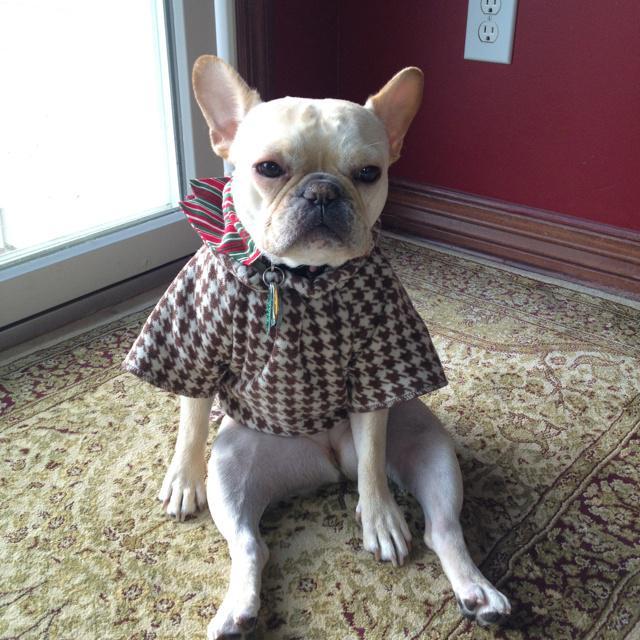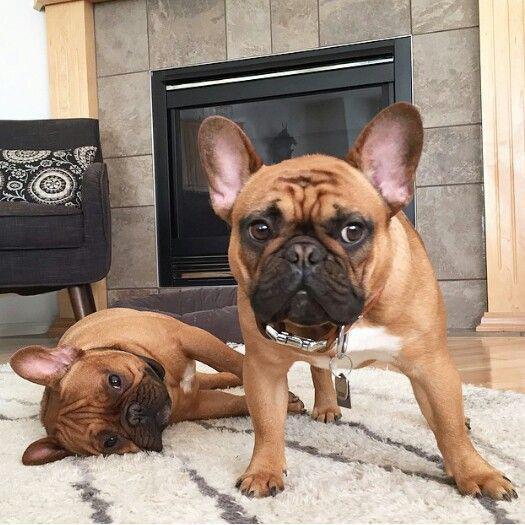The first image is the image on the left, the second image is the image on the right. Examine the images to the left and right. Is the description "An image shows exactly one dog, which is sitting." accurate? Answer yes or no. Yes. 